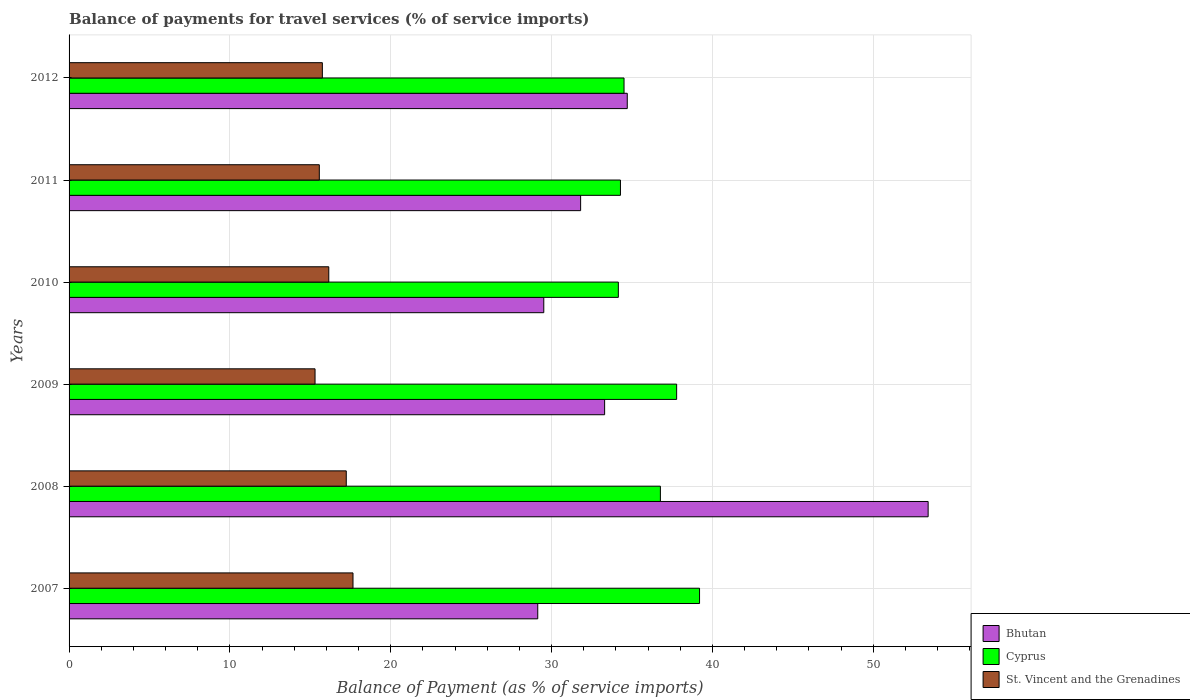How many different coloured bars are there?
Offer a terse response. 3. How many groups of bars are there?
Provide a succinct answer. 6. Are the number of bars per tick equal to the number of legend labels?
Provide a succinct answer. Yes. Are the number of bars on each tick of the Y-axis equal?
Provide a succinct answer. Yes. How many bars are there on the 3rd tick from the bottom?
Your answer should be compact. 3. What is the balance of payments for travel services in Bhutan in 2011?
Your answer should be very brief. 31.81. Across all years, what is the maximum balance of payments for travel services in Bhutan?
Make the answer very short. 53.42. Across all years, what is the minimum balance of payments for travel services in St. Vincent and the Grenadines?
Your answer should be very brief. 15.29. In which year was the balance of payments for travel services in Bhutan maximum?
Your answer should be compact. 2008. What is the total balance of payments for travel services in Cyprus in the graph?
Offer a terse response. 216.69. What is the difference between the balance of payments for travel services in Bhutan in 2008 and that in 2009?
Give a very brief answer. 20.12. What is the difference between the balance of payments for travel services in Bhutan in 2010 and the balance of payments for travel services in Cyprus in 2012?
Your response must be concise. -4.99. What is the average balance of payments for travel services in Cyprus per year?
Your response must be concise. 36.12. In the year 2010, what is the difference between the balance of payments for travel services in Bhutan and balance of payments for travel services in Cyprus?
Your response must be concise. -4.64. What is the ratio of the balance of payments for travel services in Bhutan in 2008 to that in 2010?
Your answer should be very brief. 1.81. What is the difference between the highest and the second highest balance of payments for travel services in Bhutan?
Offer a terse response. 18.71. What is the difference between the highest and the lowest balance of payments for travel services in Cyprus?
Your answer should be very brief. 5.05. In how many years, is the balance of payments for travel services in Cyprus greater than the average balance of payments for travel services in Cyprus taken over all years?
Your answer should be very brief. 3. Is the sum of the balance of payments for travel services in Bhutan in 2008 and 2012 greater than the maximum balance of payments for travel services in Cyprus across all years?
Give a very brief answer. Yes. What does the 3rd bar from the top in 2007 represents?
Ensure brevity in your answer.  Bhutan. What does the 1st bar from the bottom in 2007 represents?
Provide a succinct answer. Bhutan. Is it the case that in every year, the sum of the balance of payments for travel services in St. Vincent and the Grenadines and balance of payments for travel services in Cyprus is greater than the balance of payments for travel services in Bhutan?
Provide a succinct answer. Yes. How many bars are there?
Your answer should be very brief. 18. How many years are there in the graph?
Provide a succinct answer. 6. Are the values on the major ticks of X-axis written in scientific E-notation?
Your answer should be very brief. No. Does the graph contain any zero values?
Keep it short and to the point. No. How are the legend labels stacked?
Ensure brevity in your answer.  Vertical. What is the title of the graph?
Provide a succinct answer. Balance of payments for travel services (% of service imports). Does "El Salvador" appear as one of the legend labels in the graph?
Provide a succinct answer. No. What is the label or title of the X-axis?
Keep it short and to the point. Balance of Payment (as % of service imports). What is the Balance of Payment (as % of service imports) in Bhutan in 2007?
Offer a terse response. 29.14. What is the Balance of Payment (as % of service imports) of Cyprus in 2007?
Your response must be concise. 39.2. What is the Balance of Payment (as % of service imports) of St. Vincent and the Grenadines in 2007?
Your response must be concise. 17.65. What is the Balance of Payment (as % of service imports) in Bhutan in 2008?
Provide a succinct answer. 53.42. What is the Balance of Payment (as % of service imports) of Cyprus in 2008?
Provide a short and direct response. 36.77. What is the Balance of Payment (as % of service imports) of St. Vincent and the Grenadines in 2008?
Make the answer very short. 17.24. What is the Balance of Payment (as % of service imports) in Bhutan in 2009?
Your response must be concise. 33.3. What is the Balance of Payment (as % of service imports) of Cyprus in 2009?
Give a very brief answer. 37.78. What is the Balance of Payment (as % of service imports) of St. Vincent and the Grenadines in 2009?
Offer a very short reply. 15.29. What is the Balance of Payment (as % of service imports) of Bhutan in 2010?
Keep it short and to the point. 29.52. What is the Balance of Payment (as % of service imports) of Cyprus in 2010?
Offer a very short reply. 34.15. What is the Balance of Payment (as % of service imports) of St. Vincent and the Grenadines in 2010?
Make the answer very short. 16.15. What is the Balance of Payment (as % of service imports) in Bhutan in 2011?
Offer a very short reply. 31.81. What is the Balance of Payment (as % of service imports) of Cyprus in 2011?
Provide a short and direct response. 34.28. What is the Balance of Payment (as % of service imports) of St. Vincent and the Grenadines in 2011?
Offer a very short reply. 15.56. What is the Balance of Payment (as % of service imports) of Bhutan in 2012?
Ensure brevity in your answer.  34.71. What is the Balance of Payment (as % of service imports) of Cyprus in 2012?
Offer a terse response. 34.51. What is the Balance of Payment (as % of service imports) in St. Vincent and the Grenadines in 2012?
Provide a short and direct response. 15.75. Across all years, what is the maximum Balance of Payment (as % of service imports) of Bhutan?
Your answer should be very brief. 53.42. Across all years, what is the maximum Balance of Payment (as % of service imports) in Cyprus?
Your answer should be very brief. 39.2. Across all years, what is the maximum Balance of Payment (as % of service imports) of St. Vincent and the Grenadines?
Make the answer very short. 17.65. Across all years, what is the minimum Balance of Payment (as % of service imports) of Bhutan?
Your answer should be very brief. 29.14. Across all years, what is the minimum Balance of Payment (as % of service imports) of Cyprus?
Your answer should be compact. 34.15. Across all years, what is the minimum Balance of Payment (as % of service imports) of St. Vincent and the Grenadines?
Make the answer very short. 15.29. What is the total Balance of Payment (as % of service imports) of Bhutan in the graph?
Make the answer very short. 211.89. What is the total Balance of Payment (as % of service imports) of Cyprus in the graph?
Your response must be concise. 216.69. What is the total Balance of Payment (as % of service imports) of St. Vincent and the Grenadines in the graph?
Offer a very short reply. 97.64. What is the difference between the Balance of Payment (as % of service imports) of Bhutan in 2007 and that in 2008?
Keep it short and to the point. -24.27. What is the difference between the Balance of Payment (as % of service imports) in Cyprus in 2007 and that in 2008?
Your answer should be very brief. 2.43. What is the difference between the Balance of Payment (as % of service imports) of St. Vincent and the Grenadines in 2007 and that in 2008?
Keep it short and to the point. 0.42. What is the difference between the Balance of Payment (as % of service imports) in Bhutan in 2007 and that in 2009?
Offer a terse response. -4.16. What is the difference between the Balance of Payment (as % of service imports) in Cyprus in 2007 and that in 2009?
Ensure brevity in your answer.  1.42. What is the difference between the Balance of Payment (as % of service imports) of St. Vincent and the Grenadines in 2007 and that in 2009?
Offer a terse response. 2.36. What is the difference between the Balance of Payment (as % of service imports) in Bhutan in 2007 and that in 2010?
Keep it short and to the point. -0.37. What is the difference between the Balance of Payment (as % of service imports) in Cyprus in 2007 and that in 2010?
Ensure brevity in your answer.  5.05. What is the difference between the Balance of Payment (as % of service imports) of St. Vincent and the Grenadines in 2007 and that in 2010?
Provide a short and direct response. 1.51. What is the difference between the Balance of Payment (as % of service imports) in Bhutan in 2007 and that in 2011?
Provide a succinct answer. -2.67. What is the difference between the Balance of Payment (as % of service imports) in Cyprus in 2007 and that in 2011?
Offer a very short reply. 4.92. What is the difference between the Balance of Payment (as % of service imports) of St. Vincent and the Grenadines in 2007 and that in 2011?
Provide a succinct answer. 2.09. What is the difference between the Balance of Payment (as % of service imports) in Bhutan in 2007 and that in 2012?
Provide a succinct answer. -5.57. What is the difference between the Balance of Payment (as % of service imports) in Cyprus in 2007 and that in 2012?
Offer a very short reply. 4.7. What is the difference between the Balance of Payment (as % of service imports) of St. Vincent and the Grenadines in 2007 and that in 2012?
Offer a terse response. 1.91. What is the difference between the Balance of Payment (as % of service imports) in Bhutan in 2008 and that in 2009?
Your response must be concise. 20.11. What is the difference between the Balance of Payment (as % of service imports) in Cyprus in 2008 and that in 2009?
Provide a short and direct response. -1.01. What is the difference between the Balance of Payment (as % of service imports) of St. Vincent and the Grenadines in 2008 and that in 2009?
Keep it short and to the point. 1.94. What is the difference between the Balance of Payment (as % of service imports) of Bhutan in 2008 and that in 2010?
Your answer should be very brief. 23.9. What is the difference between the Balance of Payment (as % of service imports) of Cyprus in 2008 and that in 2010?
Provide a succinct answer. 2.61. What is the difference between the Balance of Payment (as % of service imports) of St. Vincent and the Grenadines in 2008 and that in 2010?
Keep it short and to the point. 1.09. What is the difference between the Balance of Payment (as % of service imports) in Bhutan in 2008 and that in 2011?
Keep it short and to the point. 21.61. What is the difference between the Balance of Payment (as % of service imports) of Cyprus in 2008 and that in 2011?
Give a very brief answer. 2.48. What is the difference between the Balance of Payment (as % of service imports) of St. Vincent and the Grenadines in 2008 and that in 2011?
Make the answer very short. 1.68. What is the difference between the Balance of Payment (as % of service imports) in Bhutan in 2008 and that in 2012?
Give a very brief answer. 18.71. What is the difference between the Balance of Payment (as % of service imports) in Cyprus in 2008 and that in 2012?
Ensure brevity in your answer.  2.26. What is the difference between the Balance of Payment (as % of service imports) of St. Vincent and the Grenadines in 2008 and that in 2012?
Offer a very short reply. 1.49. What is the difference between the Balance of Payment (as % of service imports) of Bhutan in 2009 and that in 2010?
Your answer should be compact. 3.78. What is the difference between the Balance of Payment (as % of service imports) in Cyprus in 2009 and that in 2010?
Ensure brevity in your answer.  3.62. What is the difference between the Balance of Payment (as % of service imports) of St. Vincent and the Grenadines in 2009 and that in 2010?
Your answer should be very brief. -0.85. What is the difference between the Balance of Payment (as % of service imports) of Bhutan in 2009 and that in 2011?
Provide a succinct answer. 1.49. What is the difference between the Balance of Payment (as % of service imports) in Cyprus in 2009 and that in 2011?
Offer a very short reply. 3.49. What is the difference between the Balance of Payment (as % of service imports) of St. Vincent and the Grenadines in 2009 and that in 2011?
Keep it short and to the point. -0.27. What is the difference between the Balance of Payment (as % of service imports) in Bhutan in 2009 and that in 2012?
Offer a very short reply. -1.41. What is the difference between the Balance of Payment (as % of service imports) of Cyprus in 2009 and that in 2012?
Your response must be concise. 3.27. What is the difference between the Balance of Payment (as % of service imports) of St. Vincent and the Grenadines in 2009 and that in 2012?
Offer a terse response. -0.46. What is the difference between the Balance of Payment (as % of service imports) in Bhutan in 2010 and that in 2011?
Provide a succinct answer. -2.29. What is the difference between the Balance of Payment (as % of service imports) in Cyprus in 2010 and that in 2011?
Your answer should be compact. -0.13. What is the difference between the Balance of Payment (as % of service imports) in St. Vincent and the Grenadines in 2010 and that in 2011?
Make the answer very short. 0.59. What is the difference between the Balance of Payment (as % of service imports) in Bhutan in 2010 and that in 2012?
Ensure brevity in your answer.  -5.19. What is the difference between the Balance of Payment (as % of service imports) in Cyprus in 2010 and that in 2012?
Your response must be concise. -0.35. What is the difference between the Balance of Payment (as % of service imports) in St. Vincent and the Grenadines in 2010 and that in 2012?
Provide a succinct answer. 0.4. What is the difference between the Balance of Payment (as % of service imports) in Cyprus in 2011 and that in 2012?
Your response must be concise. -0.22. What is the difference between the Balance of Payment (as % of service imports) of St. Vincent and the Grenadines in 2011 and that in 2012?
Provide a succinct answer. -0.19. What is the difference between the Balance of Payment (as % of service imports) in Bhutan in 2007 and the Balance of Payment (as % of service imports) in Cyprus in 2008?
Your response must be concise. -7.63. What is the difference between the Balance of Payment (as % of service imports) in Bhutan in 2007 and the Balance of Payment (as % of service imports) in St. Vincent and the Grenadines in 2008?
Offer a terse response. 11.91. What is the difference between the Balance of Payment (as % of service imports) of Cyprus in 2007 and the Balance of Payment (as % of service imports) of St. Vincent and the Grenadines in 2008?
Provide a short and direct response. 21.97. What is the difference between the Balance of Payment (as % of service imports) in Bhutan in 2007 and the Balance of Payment (as % of service imports) in Cyprus in 2009?
Keep it short and to the point. -8.64. What is the difference between the Balance of Payment (as % of service imports) of Bhutan in 2007 and the Balance of Payment (as % of service imports) of St. Vincent and the Grenadines in 2009?
Your answer should be very brief. 13.85. What is the difference between the Balance of Payment (as % of service imports) of Cyprus in 2007 and the Balance of Payment (as % of service imports) of St. Vincent and the Grenadines in 2009?
Keep it short and to the point. 23.91. What is the difference between the Balance of Payment (as % of service imports) of Bhutan in 2007 and the Balance of Payment (as % of service imports) of Cyprus in 2010?
Your answer should be compact. -5.01. What is the difference between the Balance of Payment (as % of service imports) of Bhutan in 2007 and the Balance of Payment (as % of service imports) of St. Vincent and the Grenadines in 2010?
Offer a terse response. 12.99. What is the difference between the Balance of Payment (as % of service imports) in Cyprus in 2007 and the Balance of Payment (as % of service imports) in St. Vincent and the Grenadines in 2010?
Your answer should be very brief. 23.05. What is the difference between the Balance of Payment (as % of service imports) in Bhutan in 2007 and the Balance of Payment (as % of service imports) in Cyprus in 2011?
Keep it short and to the point. -5.14. What is the difference between the Balance of Payment (as % of service imports) of Bhutan in 2007 and the Balance of Payment (as % of service imports) of St. Vincent and the Grenadines in 2011?
Your response must be concise. 13.58. What is the difference between the Balance of Payment (as % of service imports) in Cyprus in 2007 and the Balance of Payment (as % of service imports) in St. Vincent and the Grenadines in 2011?
Your response must be concise. 23.64. What is the difference between the Balance of Payment (as % of service imports) in Bhutan in 2007 and the Balance of Payment (as % of service imports) in Cyprus in 2012?
Your answer should be compact. -5.36. What is the difference between the Balance of Payment (as % of service imports) of Bhutan in 2007 and the Balance of Payment (as % of service imports) of St. Vincent and the Grenadines in 2012?
Keep it short and to the point. 13.39. What is the difference between the Balance of Payment (as % of service imports) of Cyprus in 2007 and the Balance of Payment (as % of service imports) of St. Vincent and the Grenadines in 2012?
Offer a very short reply. 23.45. What is the difference between the Balance of Payment (as % of service imports) of Bhutan in 2008 and the Balance of Payment (as % of service imports) of Cyprus in 2009?
Your answer should be very brief. 15.64. What is the difference between the Balance of Payment (as % of service imports) in Bhutan in 2008 and the Balance of Payment (as % of service imports) in St. Vincent and the Grenadines in 2009?
Your answer should be compact. 38.12. What is the difference between the Balance of Payment (as % of service imports) of Cyprus in 2008 and the Balance of Payment (as % of service imports) of St. Vincent and the Grenadines in 2009?
Provide a short and direct response. 21.47. What is the difference between the Balance of Payment (as % of service imports) of Bhutan in 2008 and the Balance of Payment (as % of service imports) of Cyprus in 2010?
Your answer should be very brief. 19.26. What is the difference between the Balance of Payment (as % of service imports) of Bhutan in 2008 and the Balance of Payment (as % of service imports) of St. Vincent and the Grenadines in 2010?
Your answer should be very brief. 37.27. What is the difference between the Balance of Payment (as % of service imports) of Cyprus in 2008 and the Balance of Payment (as % of service imports) of St. Vincent and the Grenadines in 2010?
Your answer should be compact. 20.62. What is the difference between the Balance of Payment (as % of service imports) in Bhutan in 2008 and the Balance of Payment (as % of service imports) in Cyprus in 2011?
Give a very brief answer. 19.13. What is the difference between the Balance of Payment (as % of service imports) of Bhutan in 2008 and the Balance of Payment (as % of service imports) of St. Vincent and the Grenadines in 2011?
Make the answer very short. 37.86. What is the difference between the Balance of Payment (as % of service imports) in Cyprus in 2008 and the Balance of Payment (as % of service imports) in St. Vincent and the Grenadines in 2011?
Offer a very short reply. 21.21. What is the difference between the Balance of Payment (as % of service imports) in Bhutan in 2008 and the Balance of Payment (as % of service imports) in Cyprus in 2012?
Your answer should be very brief. 18.91. What is the difference between the Balance of Payment (as % of service imports) in Bhutan in 2008 and the Balance of Payment (as % of service imports) in St. Vincent and the Grenadines in 2012?
Offer a very short reply. 37.67. What is the difference between the Balance of Payment (as % of service imports) of Cyprus in 2008 and the Balance of Payment (as % of service imports) of St. Vincent and the Grenadines in 2012?
Provide a short and direct response. 21.02. What is the difference between the Balance of Payment (as % of service imports) of Bhutan in 2009 and the Balance of Payment (as % of service imports) of Cyprus in 2010?
Your answer should be very brief. -0.85. What is the difference between the Balance of Payment (as % of service imports) in Bhutan in 2009 and the Balance of Payment (as % of service imports) in St. Vincent and the Grenadines in 2010?
Your response must be concise. 17.15. What is the difference between the Balance of Payment (as % of service imports) of Cyprus in 2009 and the Balance of Payment (as % of service imports) of St. Vincent and the Grenadines in 2010?
Provide a short and direct response. 21.63. What is the difference between the Balance of Payment (as % of service imports) in Bhutan in 2009 and the Balance of Payment (as % of service imports) in Cyprus in 2011?
Provide a succinct answer. -0.98. What is the difference between the Balance of Payment (as % of service imports) of Bhutan in 2009 and the Balance of Payment (as % of service imports) of St. Vincent and the Grenadines in 2011?
Provide a short and direct response. 17.74. What is the difference between the Balance of Payment (as % of service imports) of Cyprus in 2009 and the Balance of Payment (as % of service imports) of St. Vincent and the Grenadines in 2011?
Give a very brief answer. 22.22. What is the difference between the Balance of Payment (as % of service imports) of Bhutan in 2009 and the Balance of Payment (as % of service imports) of Cyprus in 2012?
Keep it short and to the point. -1.21. What is the difference between the Balance of Payment (as % of service imports) of Bhutan in 2009 and the Balance of Payment (as % of service imports) of St. Vincent and the Grenadines in 2012?
Your answer should be very brief. 17.55. What is the difference between the Balance of Payment (as % of service imports) of Cyprus in 2009 and the Balance of Payment (as % of service imports) of St. Vincent and the Grenadines in 2012?
Give a very brief answer. 22.03. What is the difference between the Balance of Payment (as % of service imports) in Bhutan in 2010 and the Balance of Payment (as % of service imports) in Cyprus in 2011?
Ensure brevity in your answer.  -4.77. What is the difference between the Balance of Payment (as % of service imports) of Bhutan in 2010 and the Balance of Payment (as % of service imports) of St. Vincent and the Grenadines in 2011?
Ensure brevity in your answer.  13.96. What is the difference between the Balance of Payment (as % of service imports) of Cyprus in 2010 and the Balance of Payment (as % of service imports) of St. Vincent and the Grenadines in 2011?
Provide a short and direct response. 18.59. What is the difference between the Balance of Payment (as % of service imports) of Bhutan in 2010 and the Balance of Payment (as % of service imports) of Cyprus in 2012?
Offer a very short reply. -4.99. What is the difference between the Balance of Payment (as % of service imports) in Bhutan in 2010 and the Balance of Payment (as % of service imports) in St. Vincent and the Grenadines in 2012?
Your answer should be compact. 13.77. What is the difference between the Balance of Payment (as % of service imports) of Cyprus in 2010 and the Balance of Payment (as % of service imports) of St. Vincent and the Grenadines in 2012?
Provide a succinct answer. 18.4. What is the difference between the Balance of Payment (as % of service imports) in Bhutan in 2011 and the Balance of Payment (as % of service imports) in Cyprus in 2012?
Give a very brief answer. -2.7. What is the difference between the Balance of Payment (as % of service imports) of Bhutan in 2011 and the Balance of Payment (as % of service imports) of St. Vincent and the Grenadines in 2012?
Your response must be concise. 16.06. What is the difference between the Balance of Payment (as % of service imports) in Cyprus in 2011 and the Balance of Payment (as % of service imports) in St. Vincent and the Grenadines in 2012?
Your answer should be very brief. 18.53. What is the average Balance of Payment (as % of service imports) of Bhutan per year?
Offer a terse response. 35.31. What is the average Balance of Payment (as % of service imports) in Cyprus per year?
Your answer should be compact. 36.12. What is the average Balance of Payment (as % of service imports) in St. Vincent and the Grenadines per year?
Your response must be concise. 16.27. In the year 2007, what is the difference between the Balance of Payment (as % of service imports) of Bhutan and Balance of Payment (as % of service imports) of Cyprus?
Your response must be concise. -10.06. In the year 2007, what is the difference between the Balance of Payment (as % of service imports) in Bhutan and Balance of Payment (as % of service imports) in St. Vincent and the Grenadines?
Keep it short and to the point. 11.49. In the year 2007, what is the difference between the Balance of Payment (as % of service imports) of Cyprus and Balance of Payment (as % of service imports) of St. Vincent and the Grenadines?
Your response must be concise. 21.55. In the year 2008, what is the difference between the Balance of Payment (as % of service imports) of Bhutan and Balance of Payment (as % of service imports) of Cyprus?
Keep it short and to the point. 16.65. In the year 2008, what is the difference between the Balance of Payment (as % of service imports) in Bhutan and Balance of Payment (as % of service imports) in St. Vincent and the Grenadines?
Provide a short and direct response. 36.18. In the year 2008, what is the difference between the Balance of Payment (as % of service imports) in Cyprus and Balance of Payment (as % of service imports) in St. Vincent and the Grenadines?
Provide a succinct answer. 19.53. In the year 2009, what is the difference between the Balance of Payment (as % of service imports) of Bhutan and Balance of Payment (as % of service imports) of Cyprus?
Keep it short and to the point. -4.48. In the year 2009, what is the difference between the Balance of Payment (as % of service imports) of Bhutan and Balance of Payment (as % of service imports) of St. Vincent and the Grenadines?
Offer a terse response. 18.01. In the year 2009, what is the difference between the Balance of Payment (as % of service imports) of Cyprus and Balance of Payment (as % of service imports) of St. Vincent and the Grenadines?
Your answer should be compact. 22.48. In the year 2010, what is the difference between the Balance of Payment (as % of service imports) of Bhutan and Balance of Payment (as % of service imports) of Cyprus?
Offer a terse response. -4.64. In the year 2010, what is the difference between the Balance of Payment (as % of service imports) of Bhutan and Balance of Payment (as % of service imports) of St. Vincent and the Grenadines?
Offer a terse response. 13.37. In the year 2010, what is the difference between the Balance of Payment (as % of service imports) in Cyprus and Balance of Payment (as % of service imports) in St. Vincent and the Grenadines?
Your response must be concise. 18. In the year 2011, what is the difference between the Balance of Payment (as % of service imports) in Bhutan and Balance of Payment (as % of service imports) in Cyprus?
Your answer should be compact. -2.48. In the year 2011, what is the difference between the Balance of Payment (as % of service imports) in Bhutan and Balance of Payment (as % of service imports) in St. Vincent and the Grenadines?
Give a very brief answer. 16.25. In the year 2011, what is the difference between the Balance of Payment (as % of service imports) in Cyprus and Balance of Payment (as % of service imports) in St. Vincent and the Grenadines?
Give a very brief answer. 18.72. In the year 2012, what is the difference between the Balance of Payment (as % of service imports) of Bhutan and Balance of Payment (as % of service imports) of Cyprus?
Your answer should be very brief. 0.2. In the year 2012, what is the difference between the Balance of Payment (as % of service imports) of Bhutan and Balance of Payment (as % of service imports) of St. Vincent and the Grenadines?
Keep it short and to the point. 18.96. In the year 2012, what is the difference between the Balance of Payment (as % of service imports) in Cyprus and Balance of Payment (as % of service imports) in St. Vincent and the Grenadines?
Your answer should be compact. 18.76. What is the ratio of the Balance of Payment (as % of service imports) in Bhutan in 2007 to that in 2008?
Your answer should be very brief. 0.55. What is the ratio of the Balance of Payment (as % of service imports) in Cyprus in 2007 to that in 2008?
Offer a very short reply. 1.07. What is the ratio of the Balance of Payment (as % of service imports) of St. Vincent and the Grenadines in 2007 to that in 2008?
Your answer should be very brief. 1.02. What is the ratio of the Balance of Payment (as % of service imports) in Bhutan in 2007 to that in 2009?
Keep it short and to the point. 0.88. What is the ratio of the Balance of Payment (as % of service imports) in Cyprus in 2007 to that in 2009?
Your answer should be very brief. 1.04. What is the ratio of the Balance of Payment (as % of service imports) in St. Vincent and the Grenadines in 2007 to that in 2009?
Provide a succinct answer. 1.15. What is the ratio of the Balance of Payment (as % of service imports) of Bhutan in 2007 to that in 2010?
Keep it short and to the point. 0.99. What is the ratio of the Balance of Payment (as % of service imports) in Cyprus in 2007 to that in 2010?
Provide a short and direct response. 1.15. What is the ratio of the Balance of Payment (as % of service imports) of St. Vincent and the Grenadines in 2007 to that in 2010?
Provide a short and direct response. 1.09. What is the ratio of the Balance of Payment (as % of service imports) in Bhutan in 2007 to that in 2011?
Your answer should be compact. 0.92. What is the ratio of the Balance of Payment (as % of service imports) of Cyprus in 2007 to that in 2011?
Make the answer very short. 1.14. What is the ratio of the Balance of Payment (as % of service imports) in St. Vincent and the Grenadines in 2007 to that in 2011?
Give a very brief answer. 1.13. What is the ratio of the Balance of Payment (as % of service imports) of Bhutan in 2007 to that in 2012?
Offer a terse response. 0.84. What is the ratio of the Balance of Payment (as % of service imports) in Cyprus in 2007 to that in 2012?
Give a very brief answer. 1.14. What is the ratio of the Balance of Payment (as % of service imports) of St. Vincent and the Grenadines in 2007 to that in 2012?
Give a very brief answer. 1.12. What is the ratio of the Balance of Payment (as % of service imports) of Bhutan in 2008 to that in 2009?
Your response must be concise. 1.6. What is the ratio of the Balance of Payment (as % of service imports) in Cyprus in 2008 to that in 2009?
Your answer should be very brief. 0.97. What is the ratio of the Balance of Payment (as % of service imports) in St. Vincent and the Grenadines in 2008 to that in 2009?
Provide a succinct answer. 1.13. What is the ratio of the Balance of Payment (as % of service imports) of Bhutan in 2008 to that in 2010?
Your answer should be compact. 1.81. What is the ratio of the Balance of Payment (as % of service imports) of Cyprus in 2008 to that in 2010?
Offer a very short reply. 1.08. What is the ratio of the Balance of Payment (as % of service imports) of St. Vincent and the Grenadines in 2008 to that in 2010?
Provide a succinct answer. 1.07. What is the ratio of the Balance of Payment (as % of service imports) in Bhutan in 2008 to that in 2011?
Offer a very short reply. 1.68. What is the ratio of the Balance of Payment (as % of service imports) of Cyprus in 2008 to that in 2011?
Offer a very short reply. 1.07. What is the ratio of the Balance of Payment (as % of service imports) in St. Vincent and the Grenadines in 2008 to that in 2011?
Offer a very short reply. 1.11. What is the ratio of the Balance of Payment (as % of service imports) in Bhutan in 2008 to that in 2012?
Your answer should be compact. 1.54. What is the ratio of the Balance of Payment (as % of service imports) in Cyprus in 2008 to that in 2012?
Provide a succinct answer. 1.07. What is the ratio of the Balance of Payment (as % of service imports) in St. Vincent and the Grenadines in 2008 to that in 2012?
Offer a terse response. 1.09. What is the ratio of the Balance of Payment (as % of service imports) in Bhutan in 2009 to that in 2010?
Ensure brevity in your answer.  1.13. What is the ratio of the Balance of Payment (as % of service imports) of Cyprus in 2009 to that in 2010?
Offer a very short reply. 1.11. What is the ratio of the Balance of Payment (as % of service imports) of St. Vincent and the Grenadines in 2009 to that in 2010?
Ensure brevity in your answer.  0.95. What is the ratio of the Balance of Payment (as % of service imports) in Bhutan in 2009 to that in 2011?
Provide a succinct answer. 1.05. What is the ratio of the Balance of Payment (as % of service imports) in Cyprus in 2009 to that in 2011?
Provide a succinct answer. 1.1. What is the ratio of the Balance of Payment (as % of service imports) of St. Vincent and the Grenadines in 2009 to that in 2011?
Ensure brevity in your answer.  0.98. What is the ratio of the Balance of Payment (as % of service imports) in Bhutan in 2009 to that in 2012?
Your response must be concise. 0.96. What is the ratio of the Balance of Payment (as % of service imports) in Cyprus in 2009 to that in 2012?
Provide a short and direct response. 1.09. What is the ratio of the Balance of Payment (as % of service imports) in St. Vincent and the Grenadines in 2009 to that in 2012?
Your answer should be compact. 0.97. What is the ratio of the Balance of Payment (as % of service imports) of Bhutan in 2010 to that in 2011?
Give a very brief answer. 0.93. What is the ratio of the Balance of Payment (as % of service imports) in Cyprus in 2010 to that in 2011?
Make the answer very short. 1. What is the ratio of the Balance of Payment (as % of service imports) of St. Vincent and the Grenadines in 2010 to that in 2011?
Provide a succinct answer. 1.04. What is the ratio of the Balance of Payment (as % of service imports) of Bhutan in 2010 to that in 2012?
Give a very brief answer. 0.85. What is the ratio of the Balance of Payment (as % of service imports) in St. Vincent and the Grenadines in 2010 to that in 2012?
Offer a terse response. 1.03. What is the ratio of the Balance of Payment (as % of service imports) in Bhutan in 2011 to that in 2012?
Provide a succinct answer. 0.92. What is the difference between the highest and the second highest Balance of Payment (as % of service imports) in Bhutan?
Offer a terse response. 18.71. What is the difference between the highest and the second highest Balance of Payment (as % of service imports) in Cyprus?
Provide a succinct answer. 1.42. What is the difference between the highest and the second highest Balance of Payment (as % of service imports) in St. Vincent and the Grenadines?
Keep it short and to the point. 0.42. What is the difference between the highest and the lowest Balance of Payment (as % of service imports) in Bhutan?
Your answer should be compact. 24.27. What is the difference between the highest and the lowest Balance of Payment (as % of service imports) of Cyprus?
Ensure brevity in your answer.  5.05. What is the difference between the highest and the lowest Balance of Payment (as % of service imports) in St. Vincent and the Grenadines?
Your answer should be very brief. 2.36. 